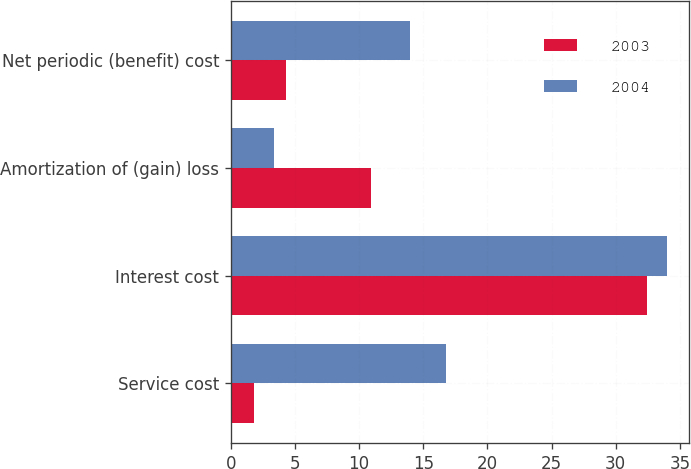Convert chart to OTSL. <chart><loc_0><loc_0><loc_500><loc_500><stacked_bar_chart><ecel><fcel>Service cost<fcel>Interest cost<fcel>Amortization of (gain) loss<fcel>Net periodic (benefit) cost<nl><fcel>2003<fcel>1.8<fcel>32.4<fcel>10.9<fcel>4.3<nl><fcel>2004<fcel>16.8<fcel>34<fcel>3.4<fcel>14<nl></chart> 